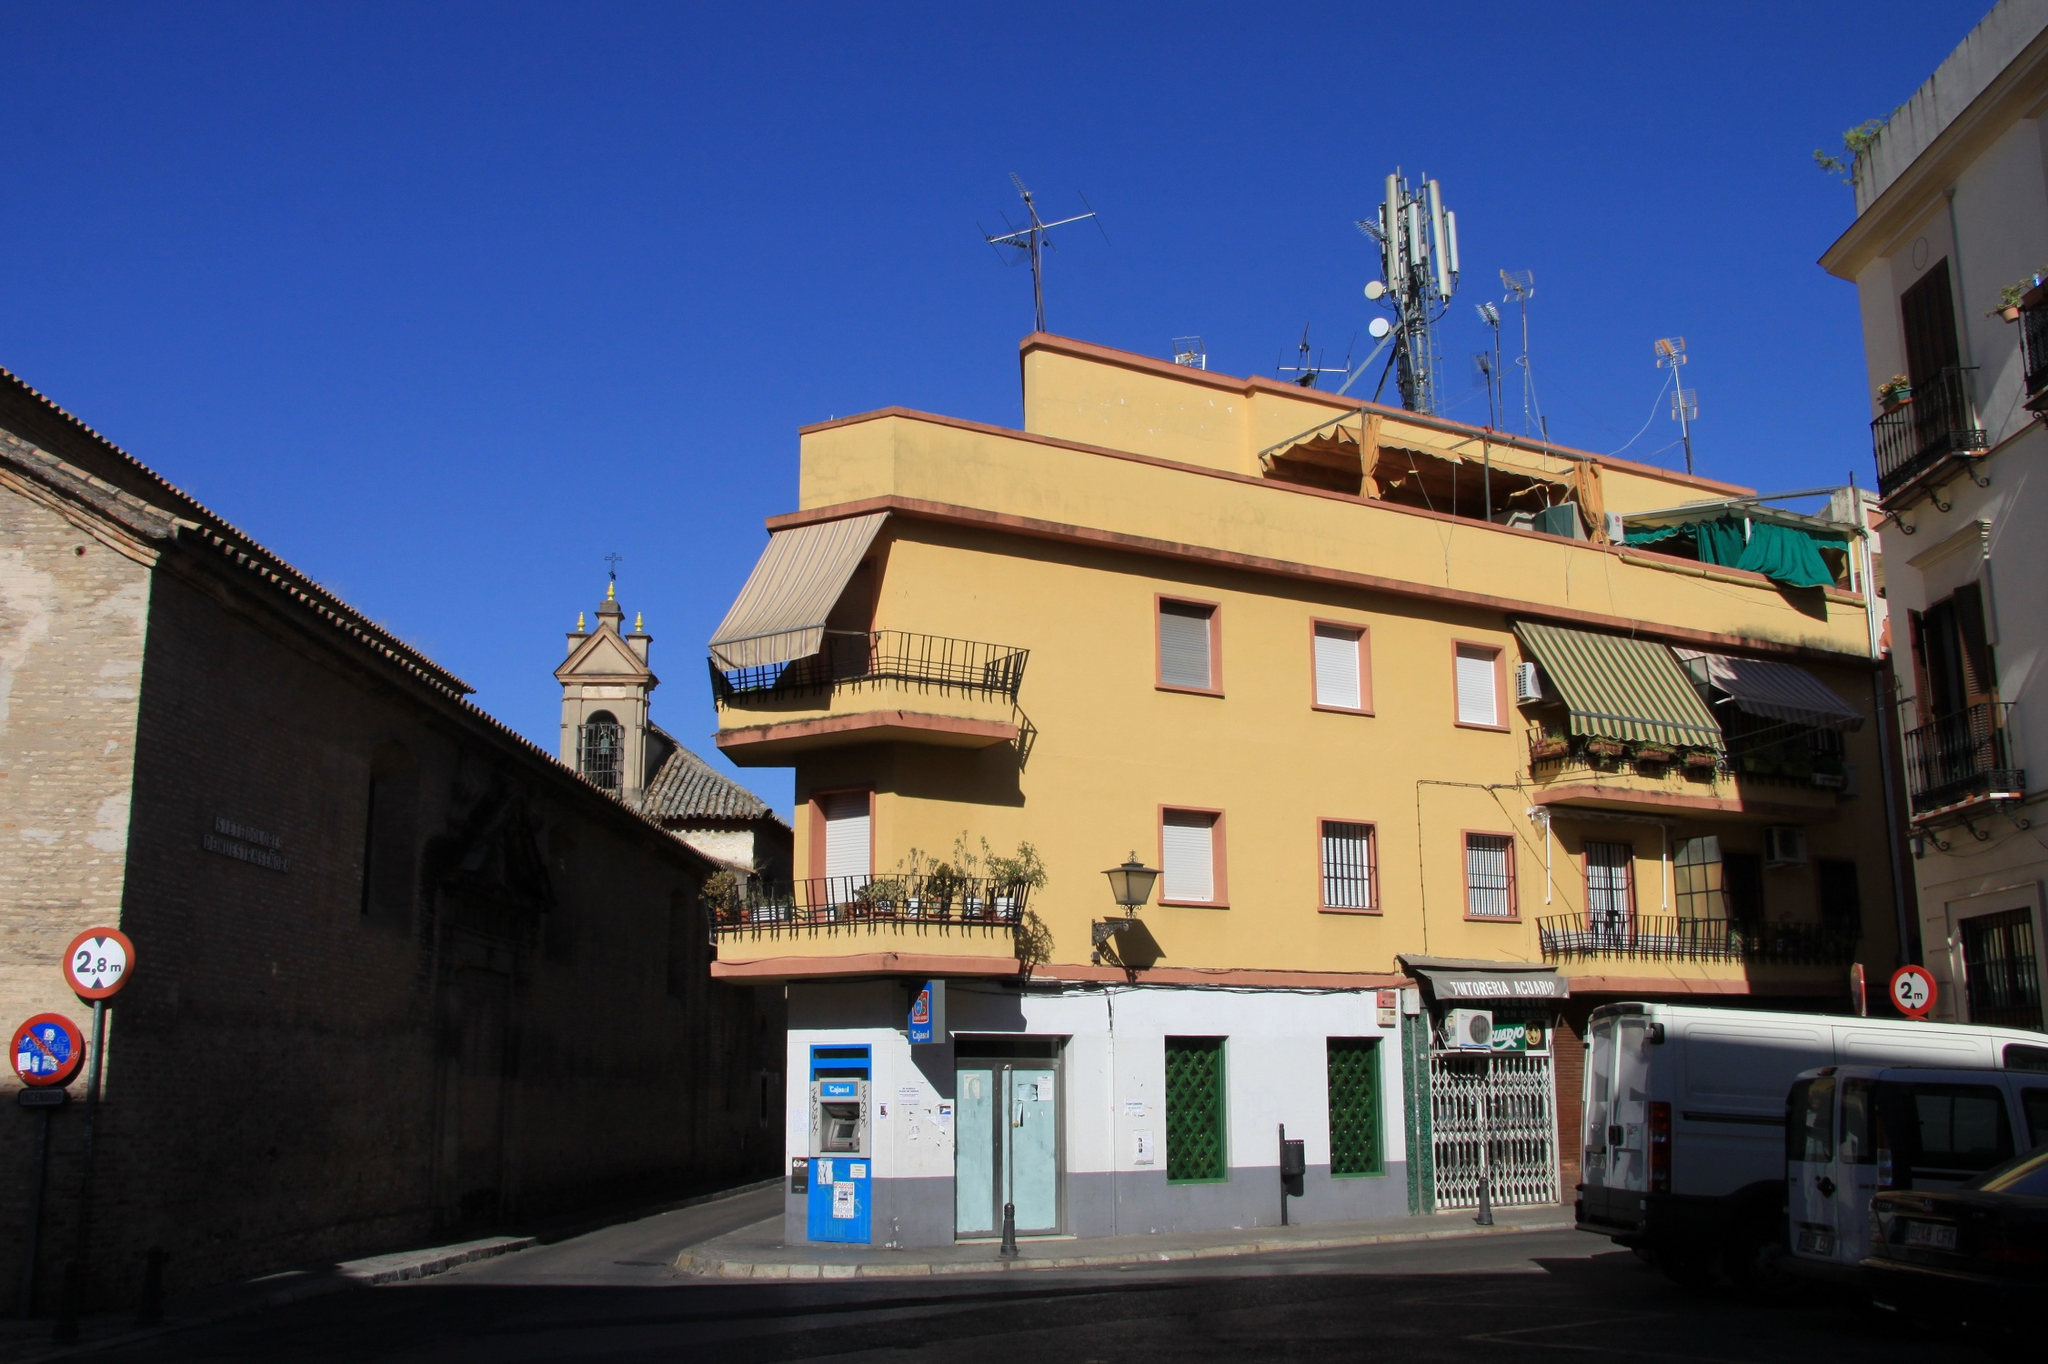Can you write a poem inspired by this image? In a European city, old and new,
A yellow building stands in view.
Balconies adorned with plants so green,
A lively scene, a vibrant sheen.

The church bell tower, tall and grand,
A historic touch to this modern land.
Beneath the clear, wide sky so blue,
Every element tells a story true.

Cars and buses, life bustling near,
Every moment, vibrant and clear.
In this corner, tales unfold,
Of history, life, both young and old.

Painted walls in sunshine's glow,
Echoes of stories from long ago.
A snapshot of life, in time's embrace,
This city corner, a cherished place. 